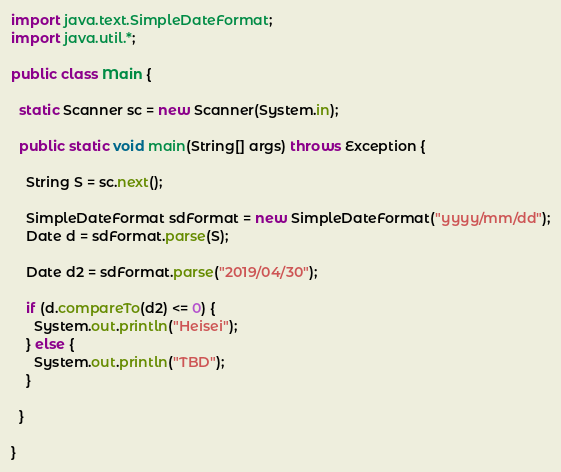Convert code to text. <code><loc_0><loc_0><loc_500><loc_500><_Java_>import java.text.SimpleDateFormat;
import java.util.*;

public class Main {

  static Scanner sc = new Scanner(System.in);

  public static void main(String[] args) throws Exception {

    String S = sc.next();

    SimpleDateFormat sdFormat = new SimpleDateFormat("yyyy/mm/dd");
    Date d = sdFormat.parse(S);

    Date d2 = sdFormat.parse("2019/04/30");

    if (d.compareTo(d2) <= 0) {
      System.out.println("Heisei");
    } else {
      System.out.println("TBD");
    }

  }

}</code> 